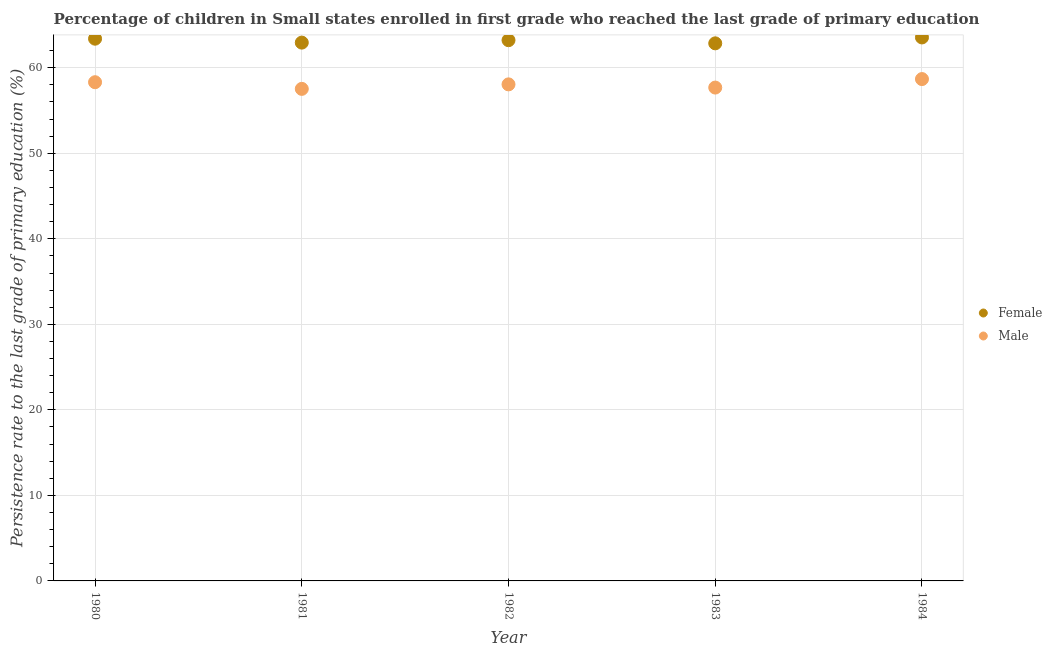What is the persistence rate of male students in 1982?
Give a very brief answer. 58.06. Across all years, what is the maximum persistence rate of female students?
Provide a short and direct response. 63.54. Across all years, what is the minimum persistence rate of female students?
Provide a short and direct response. 62.85. In which year was the persistence rate of female students maximum?
Provide a succinct answer. 1984. What is the total persistence rate of female students in the graph?
Provide a succinct answer. 315.96. What is the difference between the persistence rate of male students in 1982 and that in 1983?
Offer a very short reply. 0.37. What is the difference between the persistence rate of male students in 1982 and the persistence rate of female students in 1984?
Your answer should be very brief. -5.49. What is the average persistence rate of female students per year?
Keep it short and to the point. 63.19. In the year 1983, what is the difference between the persistence rate of male students and persistence rate of female students?
Provide a succinct answer. -5.17. What is the ratio of the persistence rate of female students in 1980 to that in 1981?
Your answer should be very brief. 1.01. Is the persistence rate of female students in 1981 less than that in 1984?
Offer a very short reply. Yes. Is the difference between the persistence rate of male students in 1980 and 1984 greater than the difference between the persistence rate of female students in 1980 and 1984?
Offer a terse response. No. What is the difference between the highest and the second highest persistence rate of male students?
Offer a terse response. 0.37. What is the difference between the highest and the lowest persistence rate of female students?
Keep it short and to the point. 0.69. Does the persistence rate of male students monotonically increase over the years?
Keep it short and to the point. No. Is the persistence rate of male students strictly greater than the persistence rate of female students over the years?
Provide a short and direct response. No. Is the persistence rate of female students strictly less than the persistence rate of male students over the years?
Make the answer very short. No. How many years are there in the graph?
Provide a succinct answer. 5. Are the values on the major ticks of Y-axis written in scientific E-notation?
Provide a succinct answer. No. Where does the legend appear in the graph?
Provide a short and direct response. Center right. How many legend labels are there?
Make the answer very short. 2. What is the title of the graph?
Keep it short and to the point. Percentage of children in Small states enrolled in first grade who reached the last grade of primary education. What is the label or title of the Y-axis?
Give a very brief answer. Persistence rate to the last grade of primary education (%). What is the Persistence rate to the last grade of primary education (%) in Female in 1980?
Keep it short and to the point. 63.4. What is the Persistence rate to the last grade of primary education (%) in Male in 1980?
Your answer should be very brief. 58.31. What is the Persistence rate to the last grade of primary education (%) of Female in 1981?
Provide a succinct answer. 62.94. What is the Persistence rate to the last grade of primary education (%) in Male in 1981?
Your answer should be compact. 57.53. What is the Persistence rate to the last grade of primary education (%) of Female in 1982?
Your answer should be very brief. 63.22. What is the Persistence rate to the last grade of primary education (%) of Male in 1982?
Provide a short and direct response. 58.06. What is the Persistence rate to the last grade of primary education (%) of Female in 1983?
Make the answer very short. 62.85. What is the Persistence rate to the last grade of primary education (%) of Male in 1983?
Ensure brevity in your answer.  57.68. What is the Persistence rate to the last grade of primary education (%) of Female in 1984?
Make the answer very short. 63.54. What is the Persistence rate to the last grade of primary education (%) of Male in 1984?
Your response must be concise. 58.68. Across all years, what is the maximum Persistence rate to the last grade of primary education (%) in Female?
Ensure brevity in your answer.  63.54. Across all years, what is the maximum Persistence rate to the last grade of primary education (%) of Male?
Keep it short and to the point. 58.68. Across all years, what is the minimum Persistence rate to the last grade of primary education (%) of Female?
Keep it short and to the point. 62.85. Across all years, what is the minimum Persistence rate to the last grade of primary education (%) in Male?
Provide a succinct answer. 57.53. What is the total Persistence rate to the last grade of primary education (%) in Female in the graph?
Offer a very short reply. 315.96. What is the total Persistence rate to the last grade of primary education (%) in Male in the graph?
Keep it short and to the point. 290.26. What is the difference between the Persistence rate to the last grade of primary education (%) of Female in 1980 and that in 1981?
Offer a very short reply. 0.46. What is the difference between the Persistence rate to the last grade of primary education (%) of Male in 1980 and that in 1981?
Your answer should be very brief. 0.78. What is the difference between the Persistence rate to the last grade of primary education (%) in Female in 1980 and that in 1982?
Offer a terse response. 0.17. What is the difference between the Persistence rate to the last grade of primary education (%) in Male in 1980 and that in 1982?
Offer a very short reply. 0.25. What is the difference between the Persistence rate to the last grade of primary education (%) in Female in 1980 and that in 1983?
Your answer should be compact. 0.54. What is the difference between the Persistence rate to the last grade of primary education (%) of Male in 1980 and that in 1983?
Your response must be concise. 0.63. What is the difference between the Persistence rate to the last grade of primary education (%) in Female in 1980 and that in 1984?
Your response must be concise. -0.15. What is the difference between the Persistence rate to the last grade of primary education (%) in Male in 1980 and that in 1984?
Give a very brief answer. -0.37. What is the difference between the Persistence rate to the last grade of primary education (%) of Female in 1981 and that in 1982?
Keep it short and to the point. -0.28. What is the difference between the Persistence rate to the last grade of primary education (%) in Male in 1981 and that in 1982?
Provide a succinct answer. -0.53. What is the difference between the Persistence rate to the last grade of primary education (%) in Female in 1981 and that in 1983?
Offer a very short reply. 0.09. What is the difference between the Persistence rate to the last grade of primary education (%) in Male in 1981 and that in 1983?
Give a very brief answer. -0.15. What is the difference between the Persistence rate to the last grade of primary education (%) in Female in 1981 and that in 1984?
Your response must be concise. -0.6. What is the difference between the Persistence rate to the last grade of primary education (%) of Male in 1981 and that in 1984?
Ensure brevity in your answer.  -1.15. What is the difference between the Persistence rate to the last grade of primary education (%) in Female in 1982 and that in 1983?
Your answer should be very brief. 0.37. What is the difference between the Persistence rate to the last grade of primary education (%) in Male in 1982 and that in 1983?
Make the answer very short. 0.37. What is the difference between the Persistence rate to the last grade of primary education (%) of Female in 1982 and that in 1984?
Your answer should be very brief. -0.32. What is the difference between the Persistence rate to the last grade of primary education (%) in Male in 1982 and that in 1984?
Keep it short and to the point. -0.62. What is the difference between the Persistence rate to the last grade of primary education (%) of Female in 1983 and that in 1984?
Ensure brevity in your answer.  -0.69. What is the difference between the Persistence rate to the last grade of primary education (%) in Male in 1983 and that in 1984?
Your answer should be compact. -0.99. What is the difference between the Persistence rate to the last grade of primary education (%) of Female in 1980 and the Persistence rate to the last grade of primary education (%) of Male in 1981?
Provide a succinct answer. 5.87. What is the difference between the Persistence rate to the last grade of primary education (%) in Female in 1980 and the Persistence rate to the last grade of primary education (%) in Male in 1982?
Your answer should be compact. 5.34. What is the difference between the Persistence rate to the last grade of primary education (%) of Female in 1980 and the Persistence rate to the last grade of primary education (%) of Male in 1983?
Your response must be concise. 5.71. What is the difference between the Persistence rate to the last grade of primary education (%) of Female in 1980 and the Persistence rate to the last grade of primary education (%) of Male in 1984?
Give a very brief answer. 4.72. What is the difference between the Persistence rate to the last grade of primary education (%) of Female in 1981 and the Persistence rate to the last grade of primary education (%) of Male in 1982?
Keep it short and to the point. 4.88. What is the difference between the Persistence rate to the last grade of primary education (%) in Female in 1981 and the Persistence rate to the last grade of primary education (%) in Male in 1983?
Your response must be concise. 5.26. What is the difference between the Persistence rate to the last grade of primary education (%) in Female in 1981 and the Persistence rate to the last grade of primary education (%) in Male in 1984?
Keep it short and to the point. 4.26. What is the difference between the Persistence rate to the last grade of primary education (%) in Female in 1982 and the Persistence rate to the last grade of primary education (%) in Male in 1983?
Your answer should be very brief. 5.54. What is the difference between the Persistence rate to the last grade of primary education (%) of Female in 1982 and the Persistence rate to the last grade of primary education (%) of Male in 1984?
Provide a short and direct response. 4.55. What is the difference between the Persistence rate to the last grade of primary education (%) in Female in 1983 and the Persistence rate to the last grade of primary education (%) in Male in 1984?
Provide a succinct answer. 4.18. What is the average Persistence rate to the last grade of primary education (%) in Female per year?
Keep it short and to the point. 63.19. What is the average Persistence rate to the last grade of primary education (%) of Male per year?
Offer a very short reply. 58.05. In the year 1980, what is the difference between the Persistence rate to the last grade of primary education (%) in Female and Persistence rate to the last grade of primary education (%) in Male?
Make the answer very short. 5.09. In the year 1981, what is the difference between the Persistence rate to the last grade of primary education (%) of Female and Persistence rate to the last grade of primary education (%) of Male?
Your response must be concise. 5.41. In the year 1982, what is the difference between the Persistence rate to the last grade of primary education (%) in Female and Persistence rate to the last grade of primary education (%) in Male?
Your answer should be compact. 5.17. In the year 1983, what is the difference between the Persistence rate to the last grade of primary education (%) in Female and Persistence rate to the last grade of primary education (%) in Male?
Offer a terse response. 5.17. In the year 1984, what is the difference between the Persistence rate to the last grade of primary education (%) in Female and Persistence rate to the last grade of primary education (%) in Male?
Provide a short and direct response. 4.87. What is the ratio of the Persistence rate to the last grade of primary education (%) in Female in 1980 to that in 1981?
Keep it short and to the point. 1.01. What is the ratio of the Persistence rate to the last grade of primary education (%) of Male in 1980 to that in 1981?
Provide a short and direct response. 1.01. What is the ratio of the Persistence rate to the last grade of primary education (%) of Female in 1980 to that in 1983?
Provide a short and direct response. 1.01. What is the ratio of the Persistence rate to the last grade of primary education (%) in Male in 1980 to that in 1983?
Give a very brief answer. 1.01. What is the ratio of the Persistence rate to the last grade of primary education (%) of Female in 1980 to that in 1984?
Make the answer very short. 1. What is the ratio of the Persistence rate to the last grade of primary education (%) in Male in 1981 to that in 1982?
Ensure brevity in your answer.  0.99. What is the ratio of the Persistence rate to the last grade of primary education (%) in Female in 1981 to that in 1983?
Make the answer very short. 1. What is the ratio of the Persistence rate to the last grade of primary education (%) of Male in 1981 to that in 1983?
Offer a very short reply. 1. What is the ratio of the Persistence rate to the last grade of primary education (%) of Female in 1981 to that in 1984?
Ensure brevity in your answer.  0.99. What is the ratio of the Persistence rate to the last grade of primary education (%) in Male in 1981 to that in 1984?
Keep it short and to the point. 0.98. What is the ratio of the Persistence rate to the last grade of primary education (%) of Female in 1982 to that in 1983?
Offer a very short reply. 1.01. What is the ratio of the Persistence rate to the last grade of primary education (%) in Male in 1982 to that in 1983?
Your response must be concise. 1.01. What is the ratio of the Persistence rate to the last grade of primary education (%) in Female in 1983 to that in 1984?
Make the answer very short. 0.99. What is the ratio of the Persistence rate to the last grade of primary education (%) in Male in 1983 to that in 1984?
Keep it short and to the point. 0.98. What is the difference between the highest and the second highest Persistence rate to the last grade of primary education (%) in Female?
Offer a very short reply. 0.15. What is the difference between the highest and the second highest Persistence rate to the last grade of primary education (%) in Male?
Your answer should be compact. 0.37. What is the difference between the highest and the lowest Persistence rate to the last grade of primary education (%) in Female?
Your response must be concise. 0.69. What is the difference between the highest and the lowest Persistence rate to the last grade of primary education (%) of Male?
Offer a terse response. 1.15. 